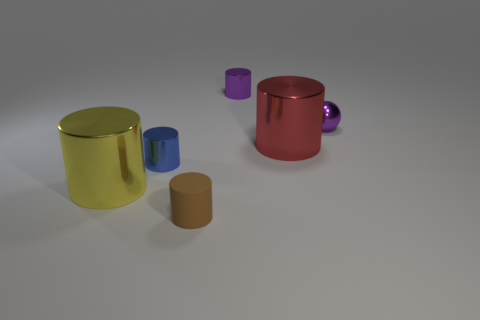Subtract all blue cylinders. How many cylinders are left? 4 Add 3 purple shiny cylinders. How many objects exist? 9 Subtract all shiny cylinders. How many cylinders are left? 1 Subtract all cyan cylinders. Subtract all purple balls. How many cylinders are left? 5 Subtract all spheres. How many objects are left? 5 Add 1 big cyan cubes. How many big cyan cubes exist? 1 Subtract 1 purple spheres. How many objects are left? 5 Subtract all big cyan balls. Subtract all metallic cylinders. How many objects are left? 2 Add 6 small spheres. How many small spheres are left? 7 